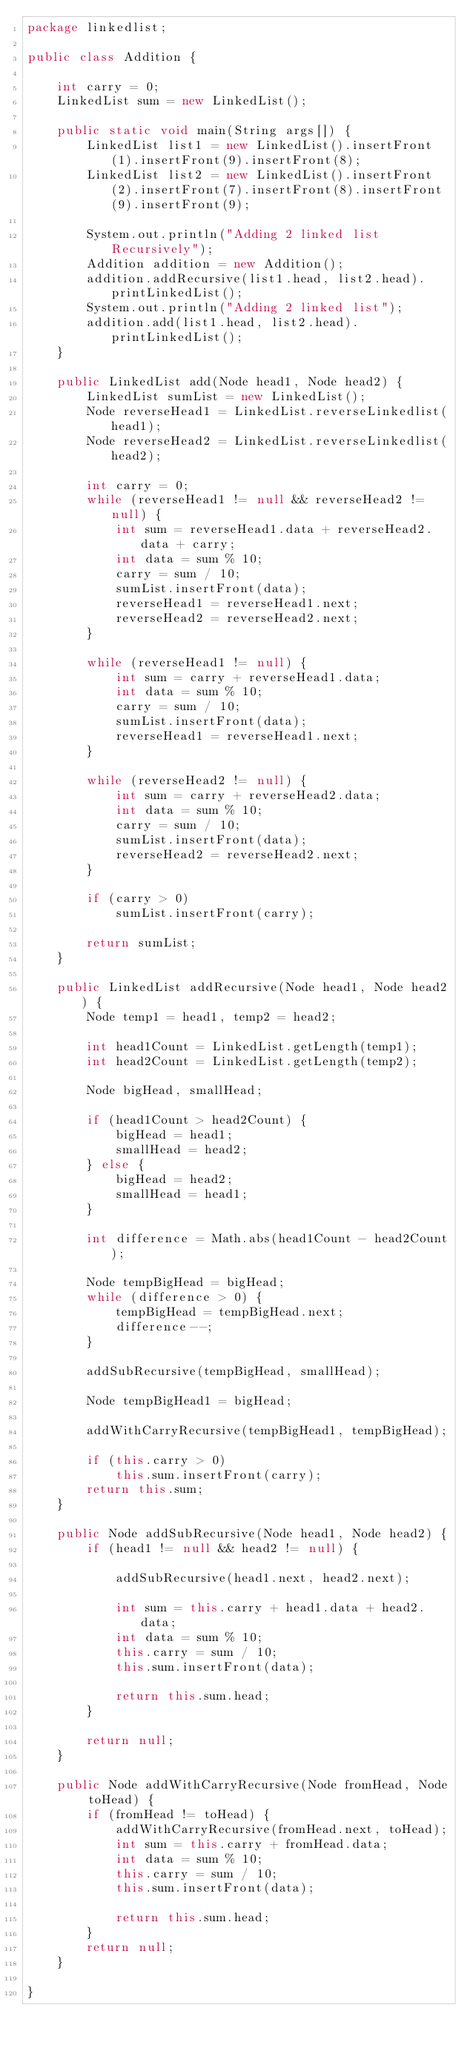<code> <loc_0><loc_0><loc_500><loc_500><_Java_>package linkedlist;

public class Addition {

    int carry = 0;
    LinkedList sum = new LinkedList();

    public static void main(String args[]) {
        LinkedList list1 = new LinkedList().insertFront(1).insertFront(9).insertFront(8);
        LinkedList list2 = new LinkedList().insertFront(2).insertFront(7).insertFront(8).insertFront(9).insertFront(9);

        System.out.println("Adding 2 linked list Recursively");
        Addition addition = new Addition();
        addition.addRecursive(list1.head, list2.head).printLinkedList();
        System.out.println("Adding 2 linked list");
        addition.add(list1.head, list2.head).printLinkedList();
    }

    public LinkedList add(Node head1, Node head2) {
        LinkedList sumList = new LinkedList();
        Node reverseHead1 = LinkedList.reverseLinkedlist(head1);
        Node reverseHead2 = LinkedList.reverseLinkedlist(head2);

        int carry = 0;
        while (reverseHead1 != null && reverseHead2 != null) {
            int sum = reverseHead1.data + reverseHead2.data + carry;
            int data = sum % 10;
            carry = sum / 10;
            sumList.insertFront(data);
            reverseHead1 = reverseHead1.next;
            reverseHead2 = reverseHead2.next;
        }

        while (reverseHead1 != null) {
            int sum = carry + reverseHead1.data;
            int data = sum % 10;
            carry = sum / 10;
            sumList.insertFront(data);
            reverseHead1 = reverseHead1.next;
        }

        while (reverseHead2 != null) {
            int sum = carry + reverseHead2.data;
            int data = sum % 10;
            carry = sum / 10;
            sumList.insertFront(data);
            reverseHead2 = reverseHead2.next;
        }

        if (carry > 0)
            sumList.insertFront(carry);

        return sumList;
    }

    public LinkedList addRecursive(Node head1, Node head2) {
        Node temp1 = head1, temp2 = head2;

        int head1Count = LinkedList.getLength(temp1);
        int head2Count = LinkedList.getLength(temp2);

        Node bigHead, smallHead;

        if (head1Count > head2Count) {
            bigHead = head1;
            smallHead = head2;
        } else {
            bigHead = head2;
            smallHead = head1;
        }

        int difference = Math.abs(head1Count - head2Count);

        Node tempBigHead = bigHead;
        while (difference > 0) {
            tempBigHead = tempBigHead.next;
            difference--;
        }

        addSubRecursive(tempBigHead, smallHead);

        Node tempBigHead1 = bigHead;

        addWithCarryRecursive(tempBigHead1, tempBigHead);

        if (this.carry > 0)
            this.sum.insertFront(carry);
        return this.sum;
    }

    public Node addSubRecursive(Node head1, Node head2) {
        if (head1 != null && head2 != null) {

            addSubRecursive(head1.next, head2.next);

            int sum = this.carry + head1.data + head2.data;
            int data = sum % 10;
            this.carry = sum / 10;
            this.sum.insertFront(data);

            return this.sum.head;
        }

        return null;
    }

    public Node addWithCarryRecursive(Node fromHead, Node toHead) {
        if (fromHead != toHead) {
            addWithCarryRecursive(fromHead.next, toHead);
            int sum = this.carry + fromHead.data;
            int data = sum % 10;
            this.carry = sum / 10;
            this.sum.insertFront(data);

            return this.sum.head;
        }
        return null;
    }

}
</code> 